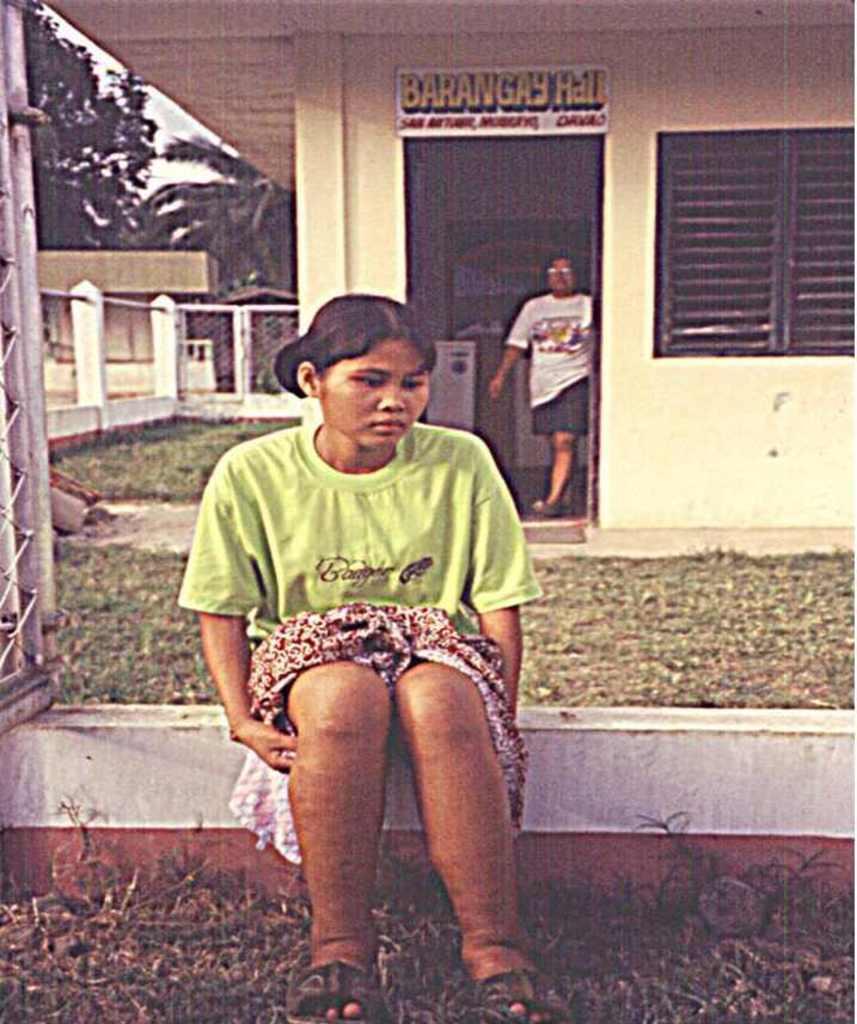Please provide a concise description of this image. In this picture there is a woman who is wearing t-shirt and shorts. She is sitting on the wall. She is sitting besides the gate. On the background we can see another woman who is standing near to the door and window. On the top we can see a board. On the left we can see fencing. On the top left corner we can see sky, clouds and trees. On the right there is a building. 